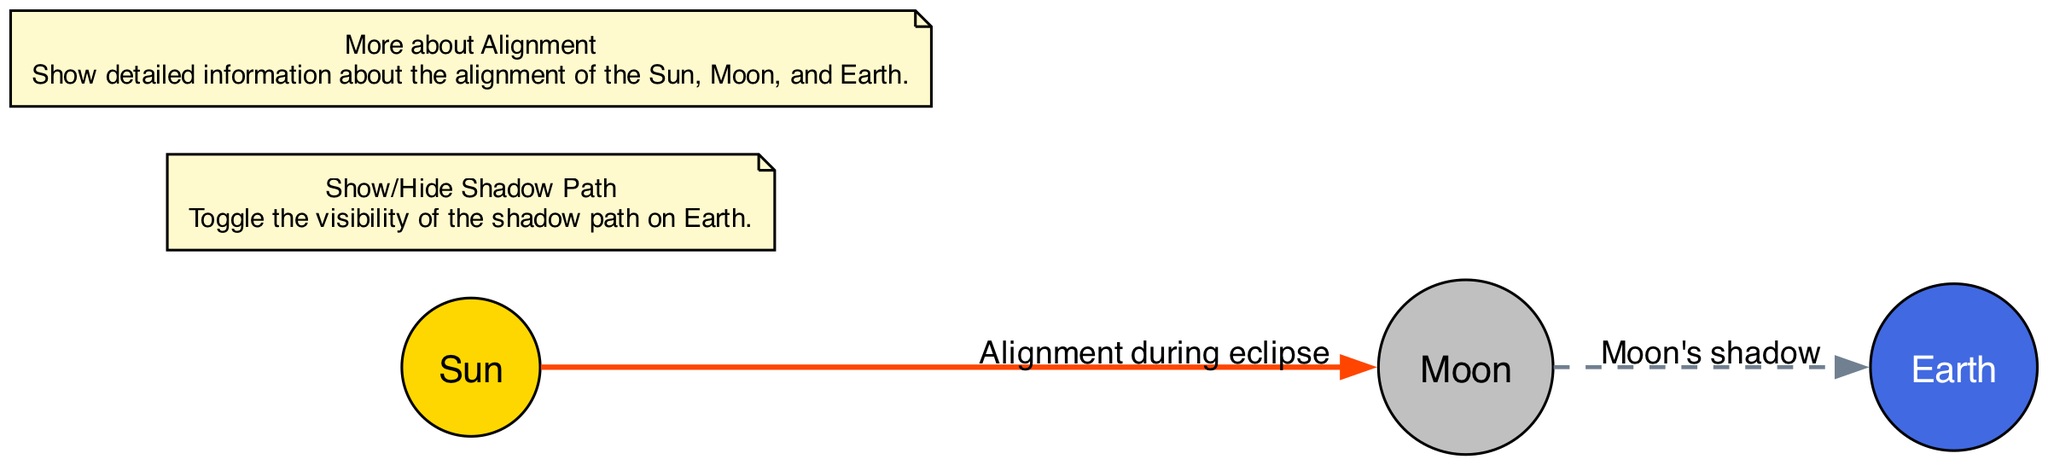What celestial object is at the center of the diagram? The diagram features three nodes, and the one labeled "Sun" is positioned at the center of the diagram, indicating that it is the central star around which the other two objects (Moon and Earth) orbit.
Answer: Sun How many nodes are represented in the diagram? The diagram includes three distinct nodes: Sun, Moon, and Earth. Therefore, the total number of nodes present is three.
Answer: 3 What does the dashed line between the Moon and Earth represent? In the diagram, the dashed line is labeled "Moon's shadow," indicating that this edge represents the path of the Moon's shadow on the Earth during an eclipse.
Answer: Moon's shadow What color is the node representing the Earth? The Earth node is represented in the diagram with the color blue, identified by the fill color corresponding to its label "Earth."
Answer: Blue What action is triggered when toggling the "Show/Hide Shadow Path"? This interactive feature allows the user to toggle the visibility of the edge labeled "Moon's shadow," which visually represents the path that the Moon’s shadow travels across the Earth.
Answer: Toggle visibility What is depicted by the edge labeled "Alignment during eclipse"? This edge illustrates the relationship where the Moon moves directly between the Sun and the Earth during an eclipse, representing the alignment necessary for this astronomical event.
Answer: Alignment during eclipse How is the Moon visually distinguished in the diagram? The Moon node is specifically distinguished in the diagram by its gray color, which is set as the fill color and aids in identifying it among the celestial objects shown.
Answer: Gray What tooltip information can be accessed regarding the alignment? The tooltip labeled "More about Alignment" provides additional detailed information concerning the alignment of the Sun, Moon, and Earth when activated.
Answer: Alignment details What type of interactivity is available for the node connection between Sun and Moon? The interactivity available for the connection between the Sun and Moon is to display additional information regarding their alignment during an eclipse, which can be accessed through a tooltip feature.
Answer: Show tooltip 